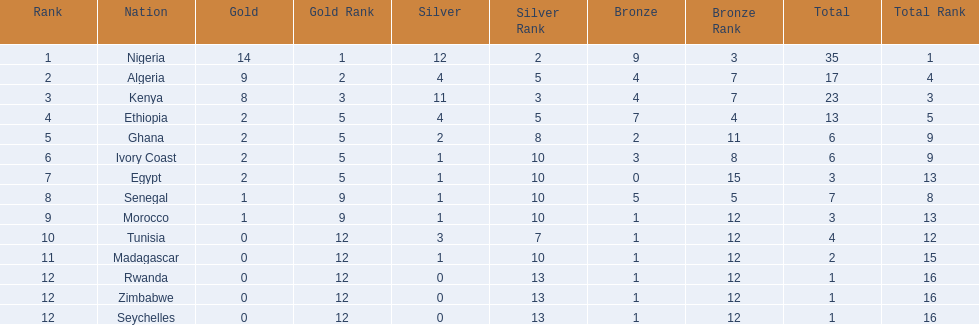Which nations competed in the 1989 african championships in athletics? Nigeria, Algeria, Kenya, Ethiopia, Ghana, Ivory Coast, Egypt, Senegal, Morocco, Tunisia, Madagascar, Rwanda, Zimbabwe, Seychelles. Of these nations, which earned 0 bronze medals? Egypt. 